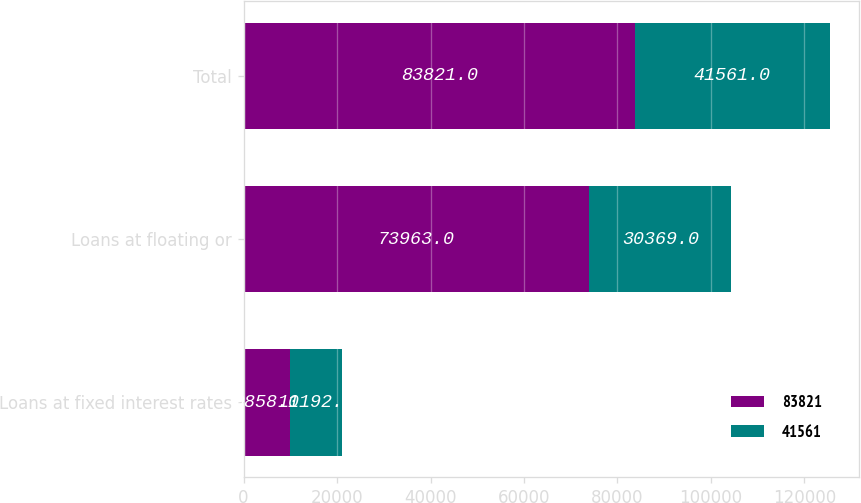Convert chart to OTSL. <chart><loc_0><loc_0><loc_500><loc_500><stacked_bar_chart><ecel><fcel>Loans at fixed interest rates<fcel>Loans at floating or<fcel>Total<nl><fcel>83821<fcel>9858<fcel>73963<fcel>83821<nl><fcel>41561<fcel>11192<fcel>30369<fcel>41561<nl></chart> 